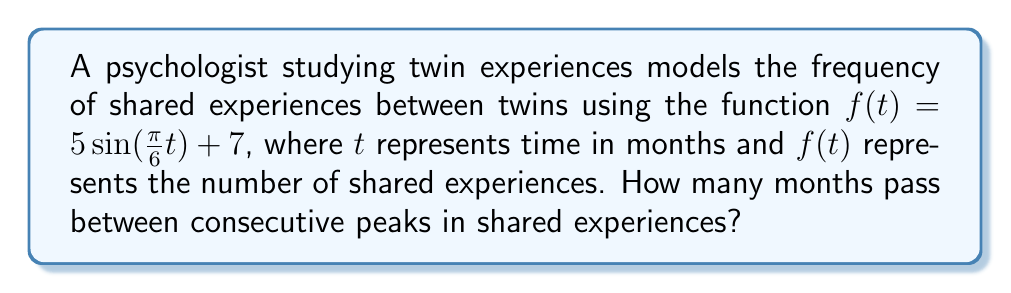Can you solve this math problem? To find the time between consecutive peaks, we need to determine the period of the sine function:

1) The general form of a sine function is:
   $a\sin(bt) + c$
   where $b$ determines the period.

2) In our function $f(t) = 5\sin(\frac{\pi}{6}t) + 7$, we have $b = \frac{\pi}{6}$

3) The period of a sine function is given by:
   $\text{Period} = \frac{2\pi}{|b|}$

4) Substituting our $b$ value:
   $\text{Period} = \frac{2\pi}{|\frac{\pi}{6}|} = \frac{2\pi}{\frac{\pi}{6}} = 2 \cdot 6 = 12$

5) Therefore, the period of the function is 12 months.

This means that the pattern of shared experiences repeats every 12 months, and consecutive peaks occur at intervals of 12 months.
Answer: 12 months 